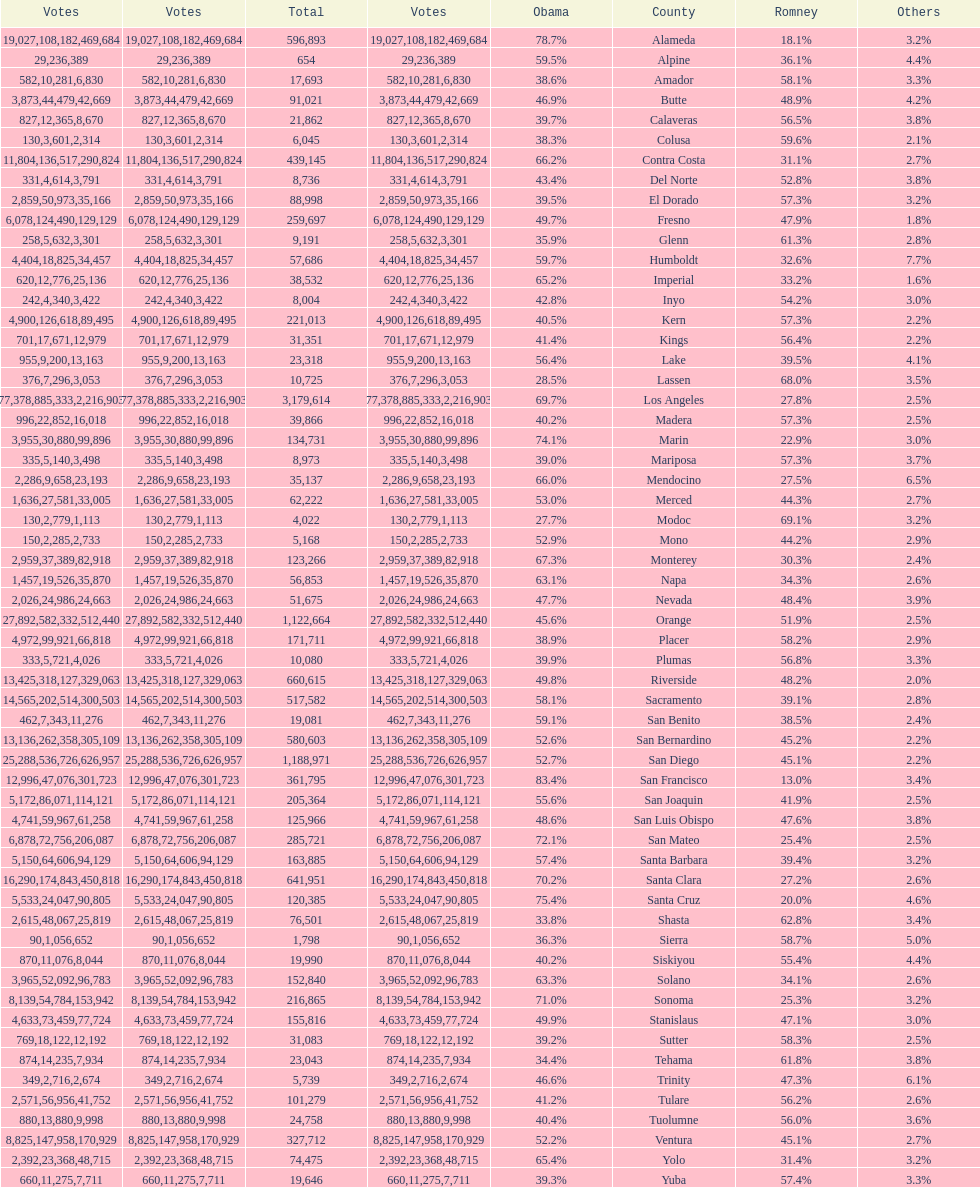Which count had the least number of votes for obama? Modoc. 